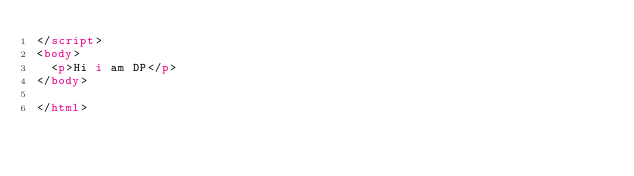Convert code to text. <code><loc_0><loc_0><loc_500><loc_500><_HTML_></script>
<body>
  <p>Hi i am DP</p>
</body>

</html>
</code> 